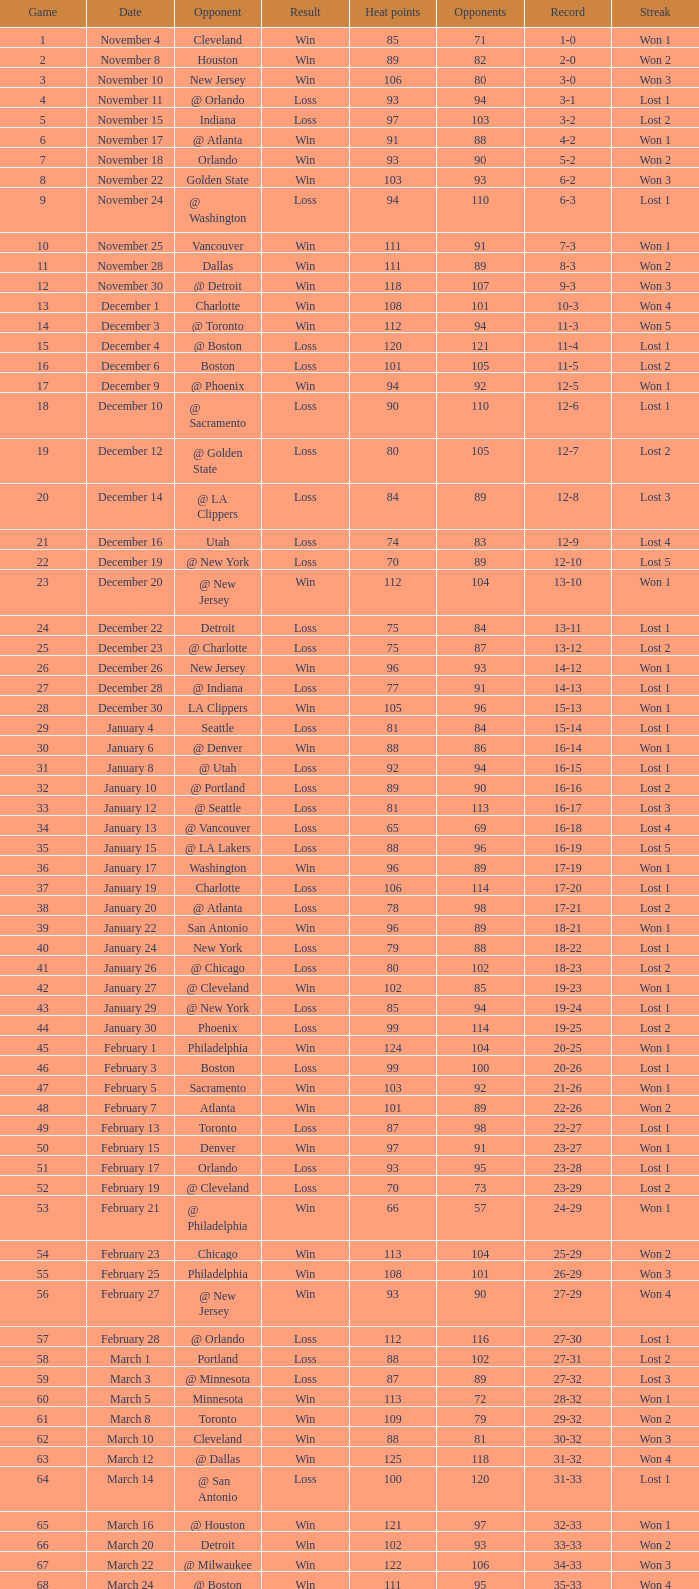What is the typical heat points when the result is "loss", game is above 72, and the date is "april 21"? 92.0. 